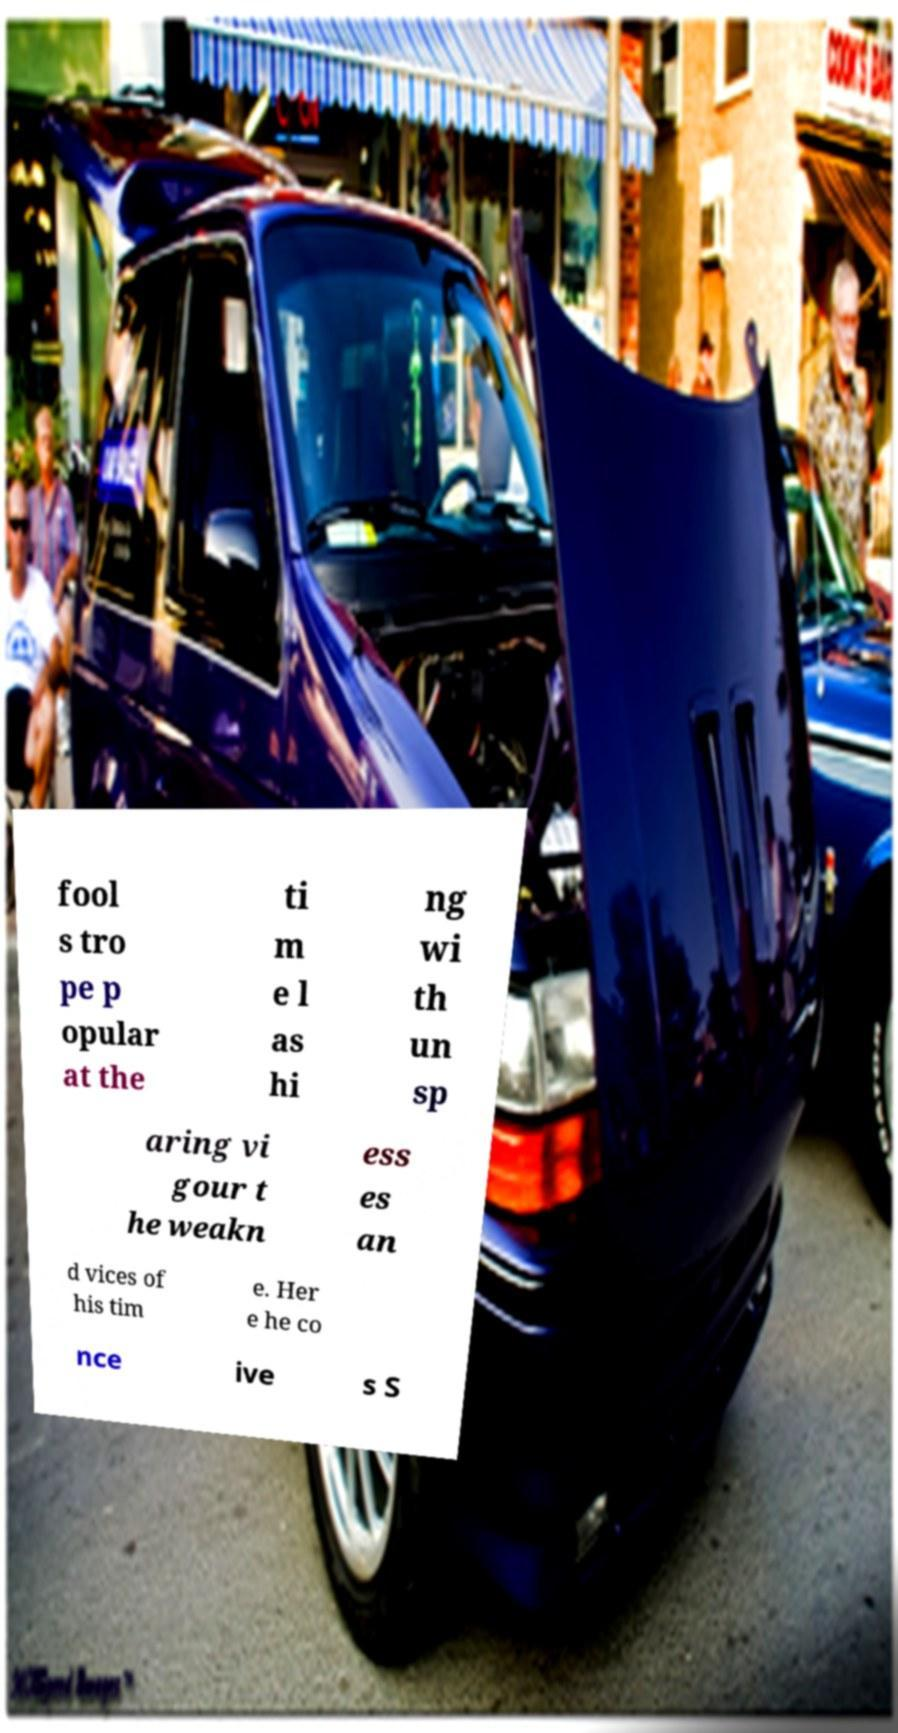For documentation purposes, I need the text within this image transcribed. Could you provide that? fool s tro pe p opular at the ti m e l as hi ng wi th un sp aring vi gour t he weakn ess es an d vices of his tim e. Her e he co nce ive s S 